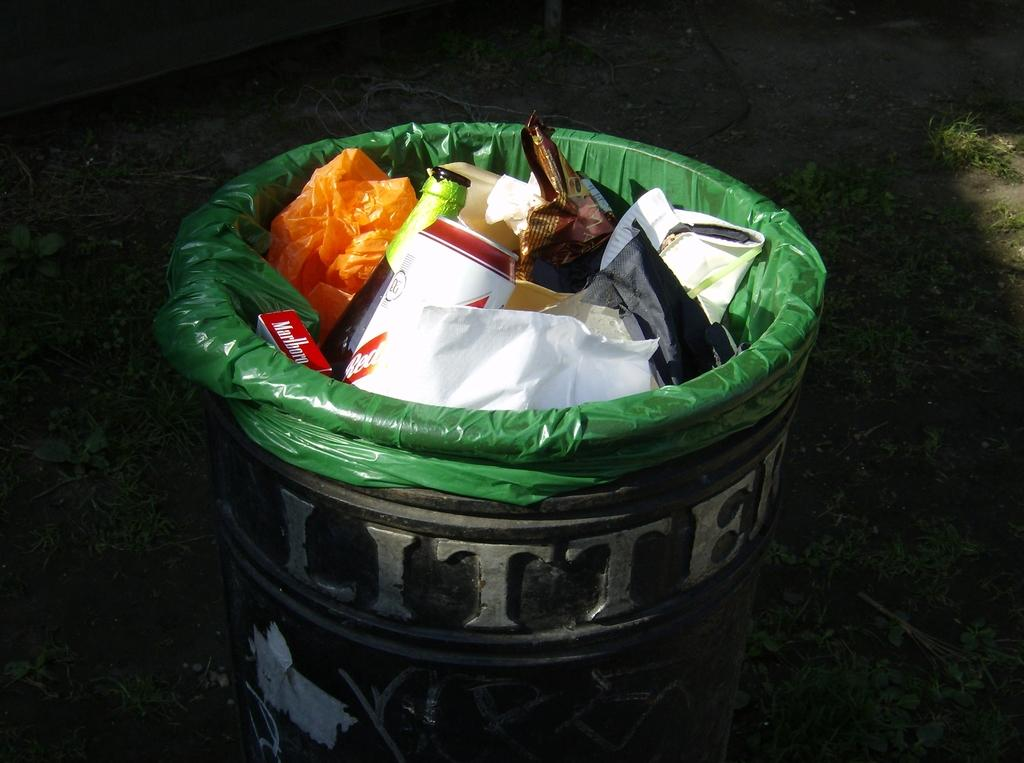<image>
Provide a brief description of the given image. A litter bin filled with litter including an empty Marlboro box. 